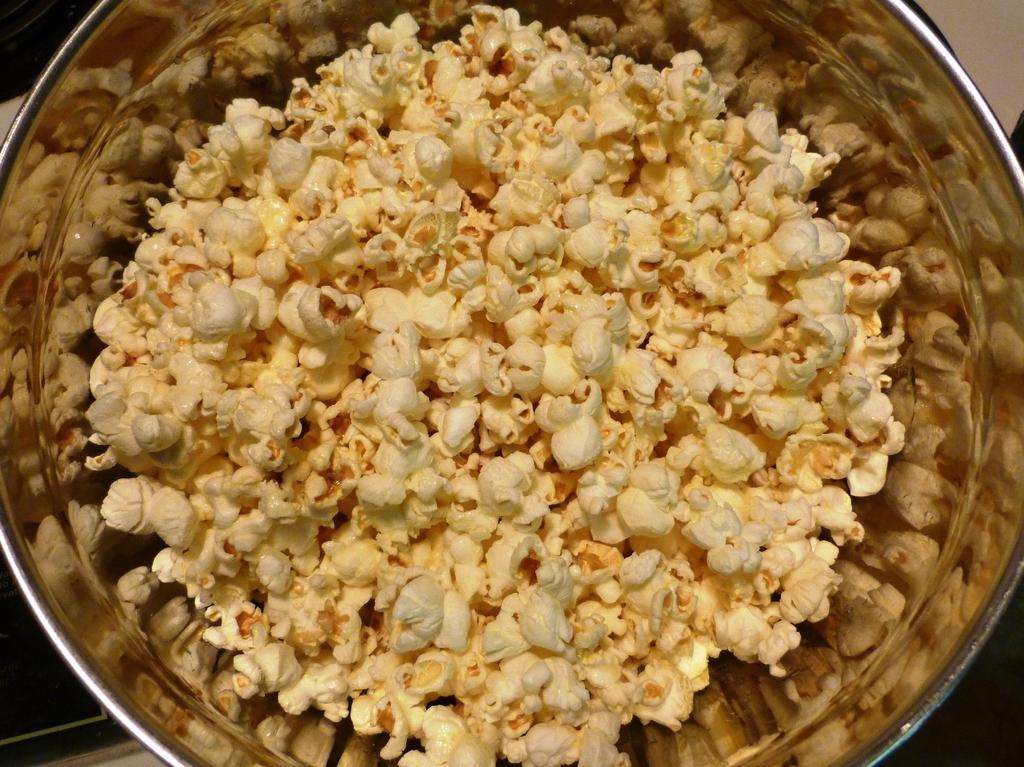What is in the bowl that is visible in the image? The bowl contains popcorn. Can you describe the contents of the bowl in more detail? The bowl contains popcorn, which is a popular snack made from corn kernels that have been heated until they pop. What type of peace treaty is being signed in the image? There is no peace treaty or any indication of a signing ceremony in the image; it only shows a bowl containing popcorn. 